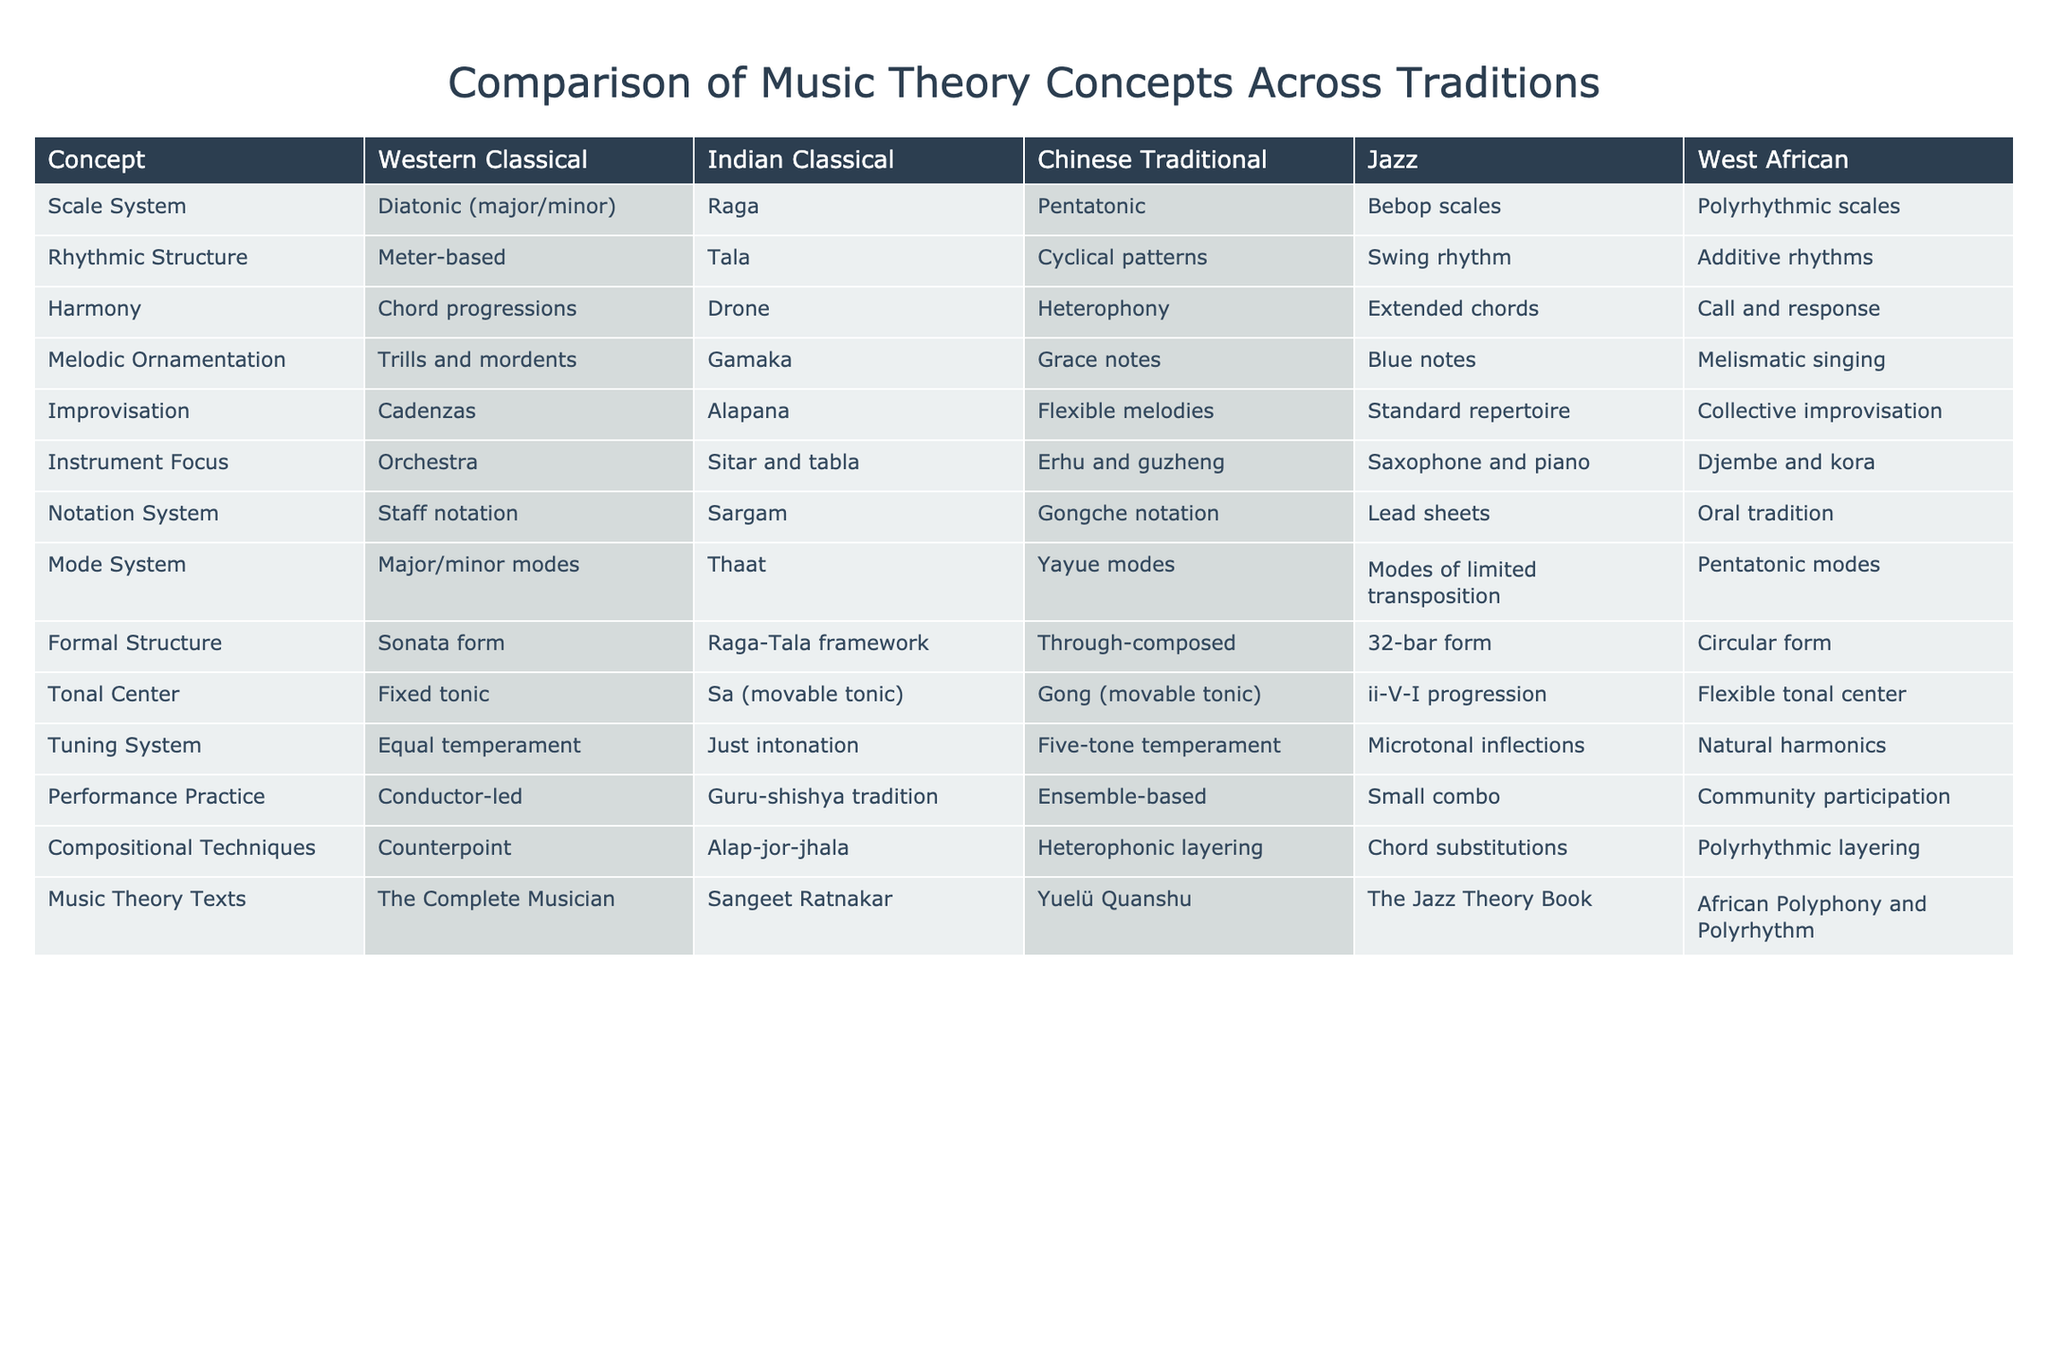What scale system is used in Western Classical music? The scale system for Western Classical music is Diatonic (major/minor), as stated in the table under the "Scale System" row for that tradition.
Answer: Diatonic (major/minor) Is the rhythmic structure in Indian Classical music based on meter? No, the rhythmic structure in Indian Classical music is based on Tala, which is not meter-based but rather a cyclical pattern of beats.
Answer: No Which tradition emphasizes improvisation through collective participation? West African music emphasizes improvisation through collective participation, as noted in the "Improvisation" row where it states Collective improvisation under West African.
Answer: West African What is the primary instrument focus in Jazz? The primary instruments in Jazz, according to the table, are Saxophone and piano, as listed in the "Instrument Focus" row for the Jazz tradition.
Answer: Saxophone and piano Among the music traditions listed, which one uses a drone for harmony? The tradition that uses a drone for harmony is Indian Classical, as indicated in the "Harmony" category, where it states Drone for Indian Classical music.
Answer: Indian Classical What is the mode system of Chinese Traditional music? The mode system of Chinese Traditional music is Yayue modes, as indicated in the "Mode System" row under Chinese Traditional.
Answer: Yayue modes In which music tradition is the notation system oral? The notation system for West African music is oral, as indicated under "Notation System" for West African in the table.
Answer: West African Which tradition features a tuning system that includes Just intonation? The tradition that features a tuning system including Just intonation is Indian Classical music, as seen in the "Tuning System" row.
Answer: Indian Classical How many different harmonic approaches are listed for Jazz and West African music? Jazz employs Extended chords, while West African music uses Call and response for harmony. Thus, there are two different harmonic approaches listed for these traditions.
Answer: 2 